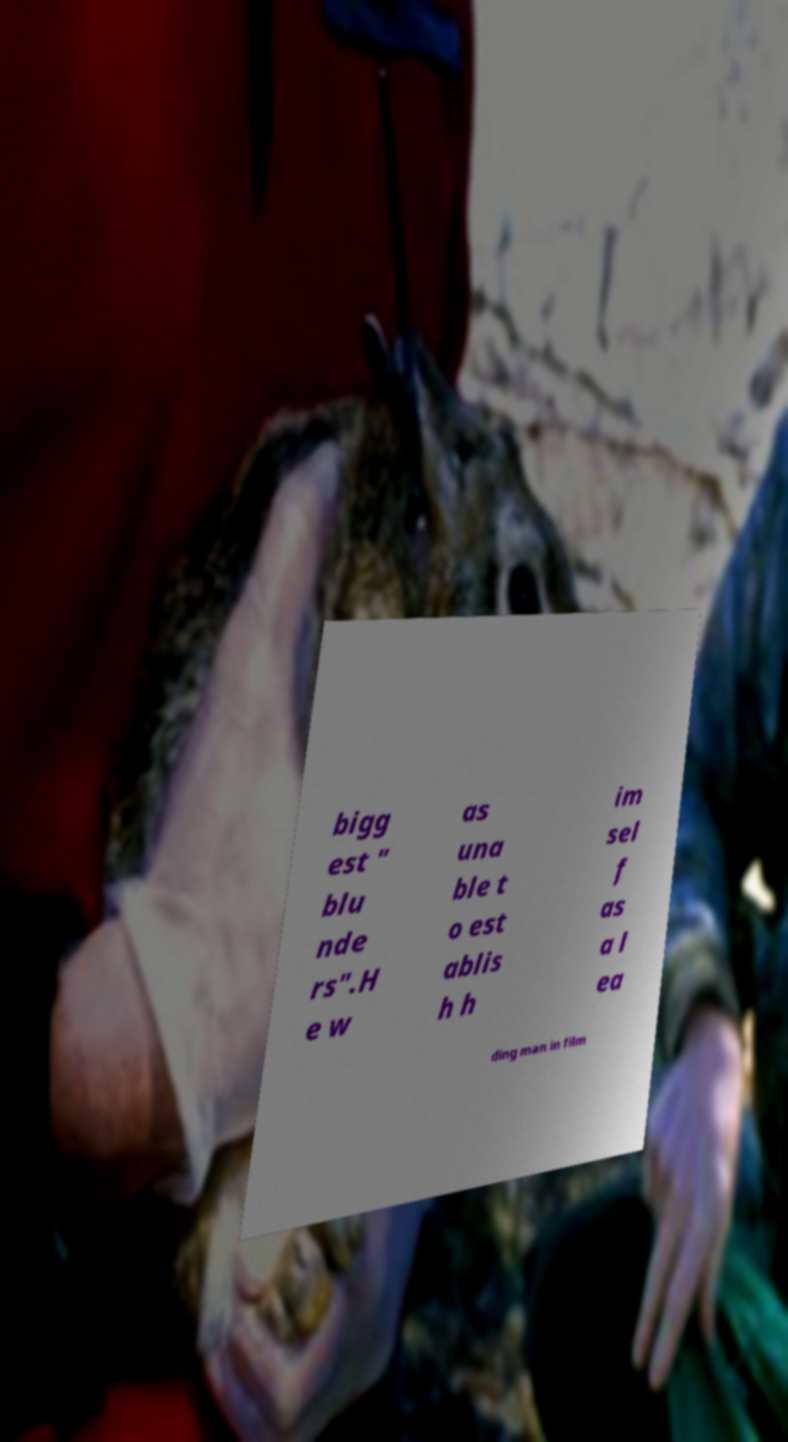Can you accurately transcribe the text from the provided image for me? bigg est " blu nde rs".H e w as una ble t o est ablis h h im sel f as a l ea ding man in film 